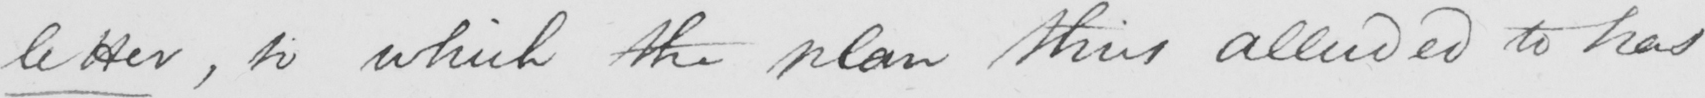What does this handwritten line say? letter , to which the plan thus alluded to has 